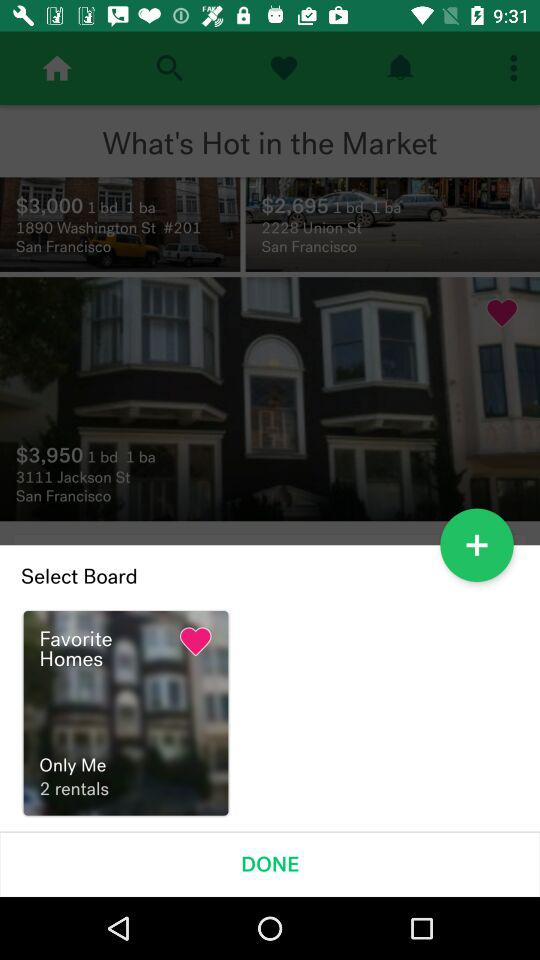How many rentals are shown in "Favorite Homes"?
Answer the question using a single word or phrase. There are 2 rentals shown in "Favorite Homes." 